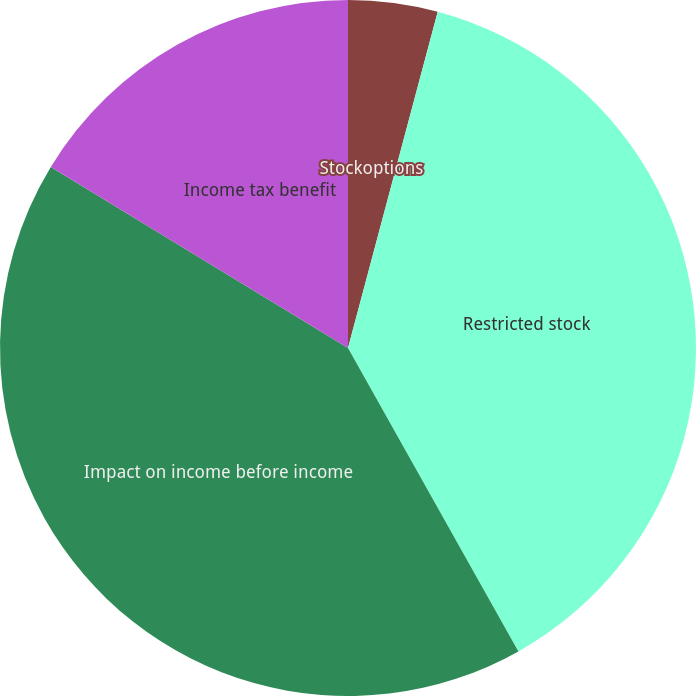Convert chart. <chart><loc_0><loc_0><loc_500><loc_500><pie_chart><fcel>Stockoptions<fcel>Restricted stock<fcel>Impact on income before income<fcel>Income tax benefit<nl><fcel>4.15%<fcel>37.7%<fcel>41.85%<fcel>16.29%<nl></chart> 